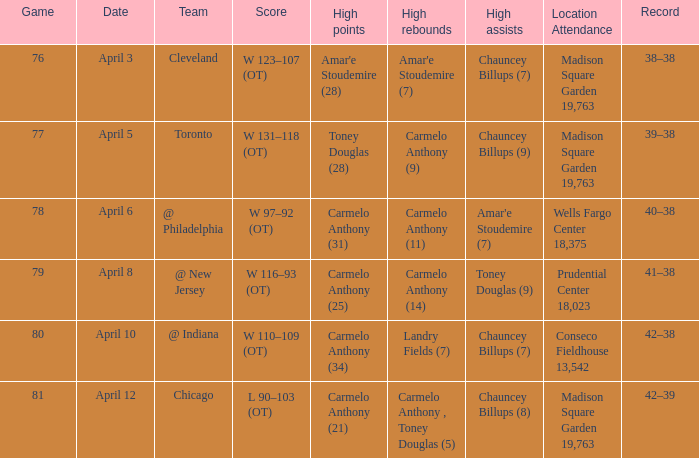Name the date for cleveland April 3. 